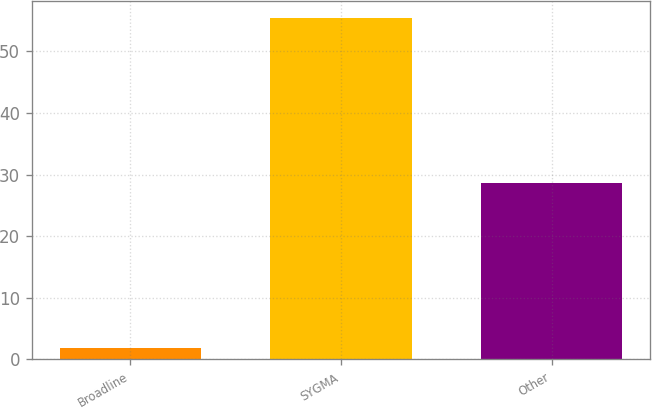<chart> <loc_0><loc_0><loc_500><loc_500><bar_chart><fcel>Broadline<fcel>SYGMA<fcel>Other<nl><fcel>1.9<fcel>55.4<fcel>28.6<nl></chart> 